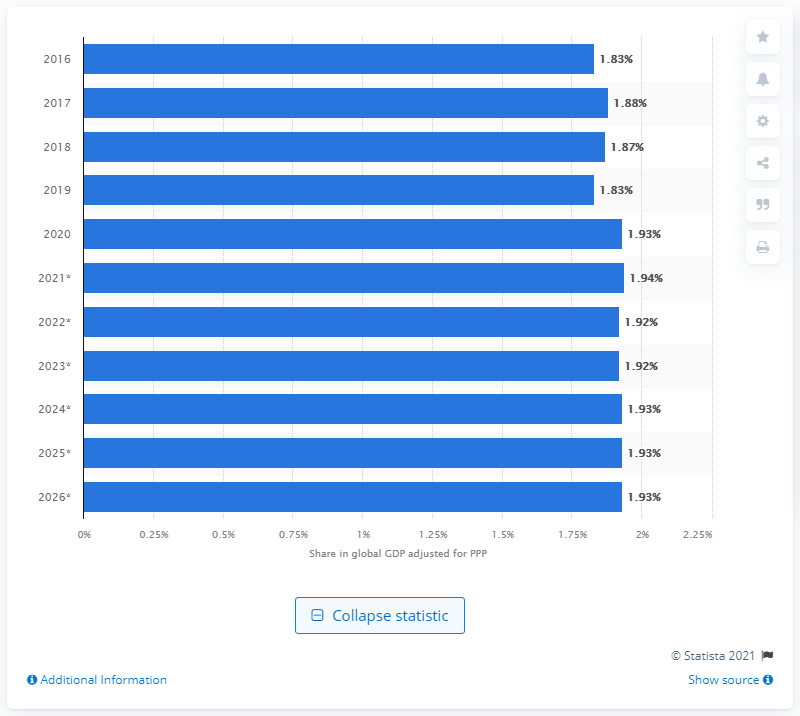Point out several critical features in this image. In 2020, Turkey's share of the Gross Domestic Product (GDP) was 1.93%. 